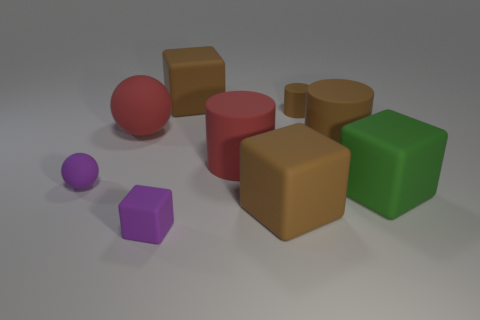Subtract 1 blocks. How many blocks are left? 3 Add 1 small purple blocks. How many objects exist? 10 Subtract all balls. How many objects are left? 7 Add 7 large brown objects. How many large brown objects exist? 10 Subtract 1 brown blocks. How many objects are left? 8 Subtract all big green rubber cubes. Subtract all brown matte blocks. How many objects are left? 6 Add 7 big brown things. How many big brown things are left? 10 